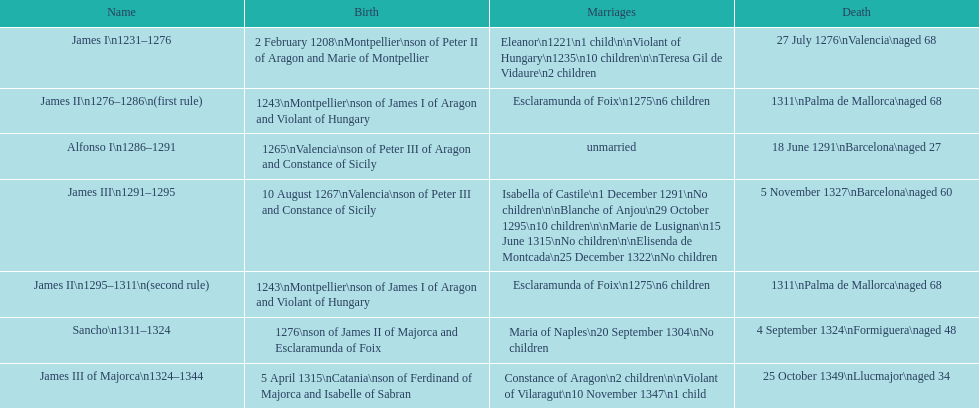Which ruler had the highest number of marriages? James III 1291-1295. 